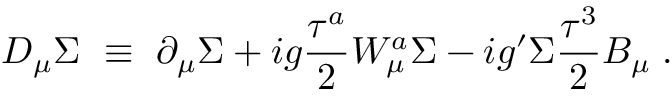Convert formula to latex. <formula><loc_0><loc_0><loc_500><loc_500>D _ { \mu } \Sigma \equiv \partial _ { \mu } \Sigma + i g \frac { \tau ^ { a } } { 2 } W _ { \mu } ^ { a } \Sigma - i g ^ { \prime } \Sigma \frac { \tau ^ { 3 } } { 2 } B _ { \mu } \, .</formula> 